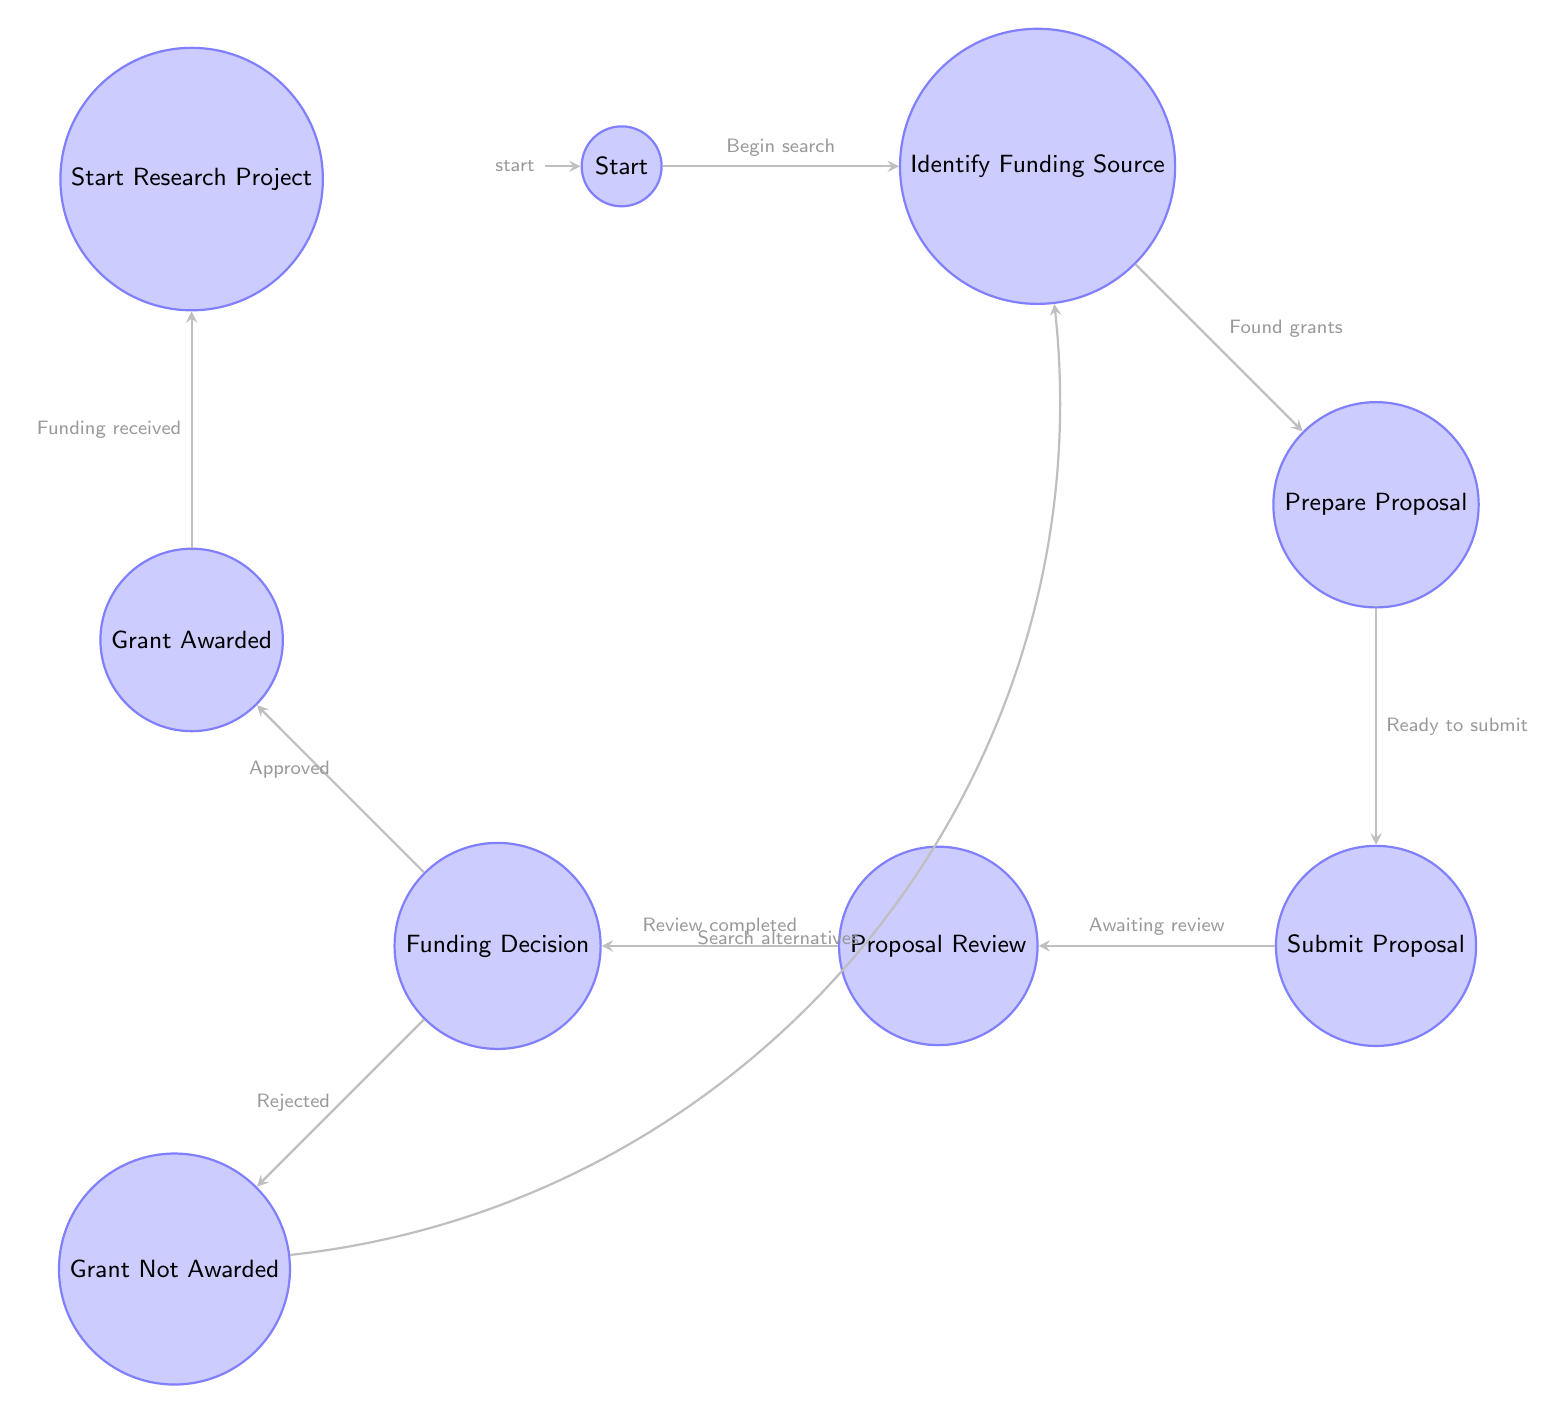What is the starting node of the workflow? The starting node is labeled "Start", which is the initial point of the workflow for obtaining research grants.
Answer: Start How many states are there in the diagram? The diagram includes nine states: Start, Identify Funding Source, Prepare Proposal, Submit Proposal, Proposal Review, Funding Decision, Grant Awarded, Grant Not Awarded, and Start Research Project.
Answer: Nine From which node does the proposal review process initiate? The proposal review process initiates from the "Submit Proposal" node, indicating that once a proposal is submitted, it enters the review stage.
Answer: Submit Proposal What happens after the grant is awarded? After the grant is awarded, the next action is to "Start Research Project", indicating that funding received allows for the commencement of the research.
Answer: Start Research Project If the funding decision is "Rejected", what is the next step? If the funding decision is "Rejected," the next step is to "Identify Funding Source," prompting the search for alternative funding opportunities.
Answer: Identify Funding Source What are the two possible outcomes after the funding decision? The two possible outcomes after the funding decision are "Grant Awarded" and "Grant Not Awarded," reflecting the dual scenarios of the funding process.
Answer: Grant Awarded, Grant Not Awarded How does the workflow return after a proposal is not awarded? The workflow returns to the "Identify Funding Source" state, indicating the need to search for other funding opportunities after a proposal is not awarded.
Answer: Identify Funding Source What transition occurs after proposal preparation? After proposal preparation, the transition is to the "Submit Proposal" state, signifying readiness to submit the proposal to the funders.
Answer: Submit Proposal 